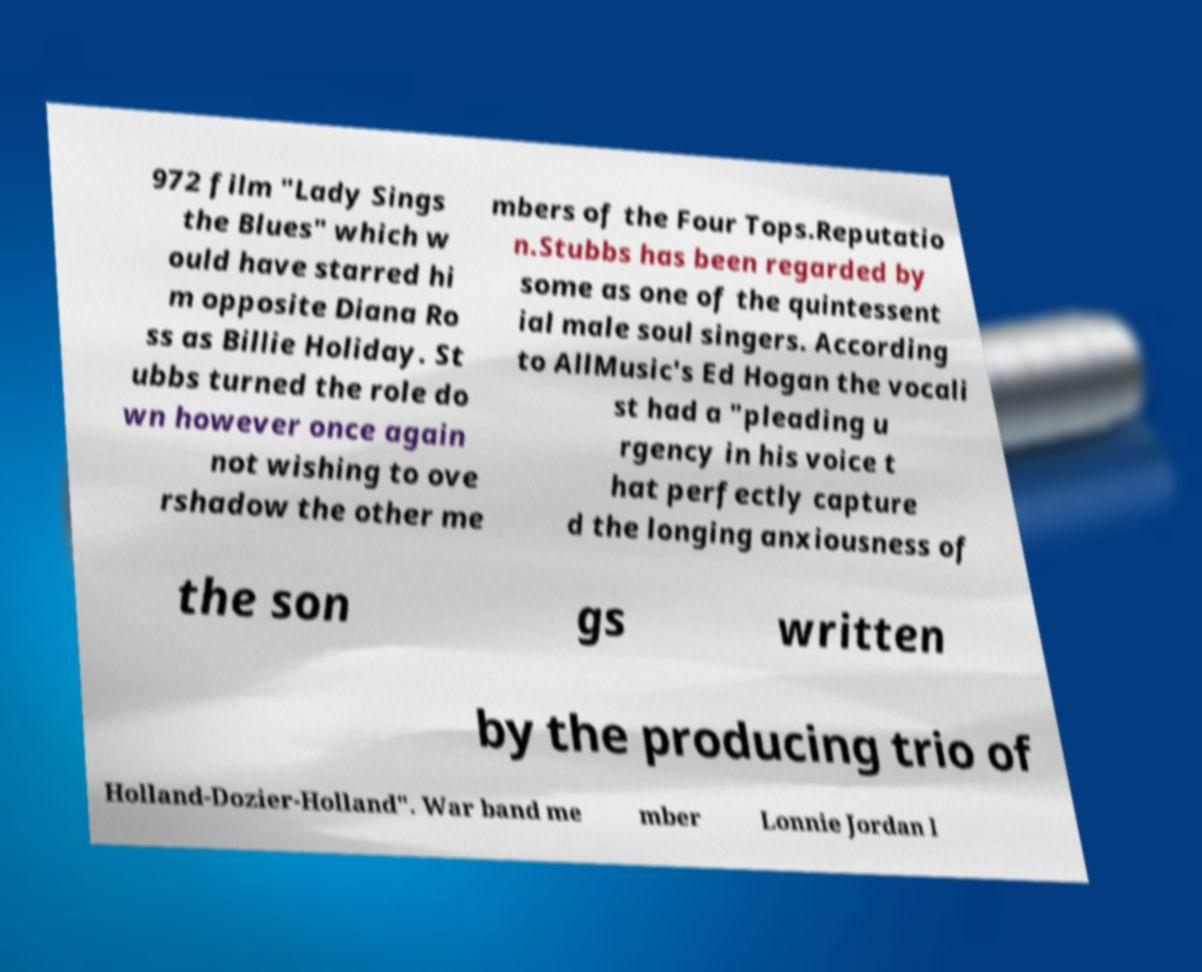Can you read and provide the text displayed in the image?This photo seems to have some interesting text. Can you extract and type it out for me? 972 film "Lady Sings the Blues" which w ould have starred hi m opposite Diana Ro ss as Billie Holiday. St ubbs turned the role do wn however once again not wishing to ove rshadow the other me mbers of the Four Tops.Reputatio n.Stubbs has been regarded by some as one of the quintessent ial male soul singers. According to AllMusic's Ed Hogan the vocali st had a "pleading u rgency in his voice t hat perfectly capture d the longing anxiousness of the son gs written by the producing trio of Holland-Dozier-Holland". War band me mber Lonnie Jordan l 